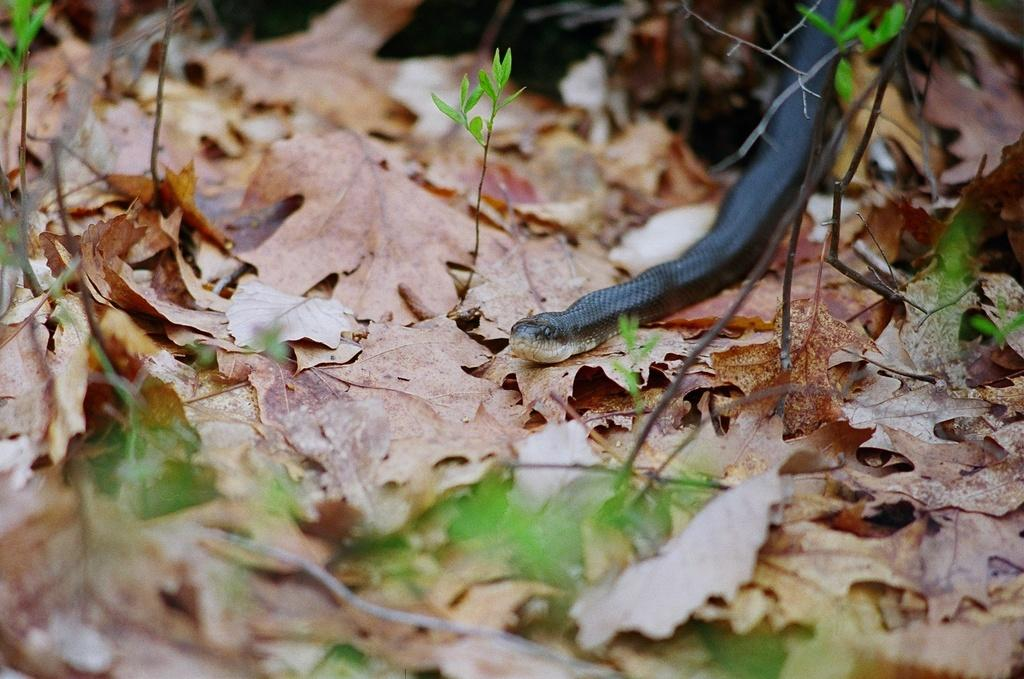What type of natural material can be seen in the image? There are dry leaves in the image. What type of vegetation is present in the image? There are small plants in the image. What type of animal can be seen in the image? There is a snake in the image. How many chairs are visible in the image? There are no chairs present in the image. What type of sea creature can be seen in the image? There are no sea creatures present in the image; it features dry leaves, small plants, and a snake. 